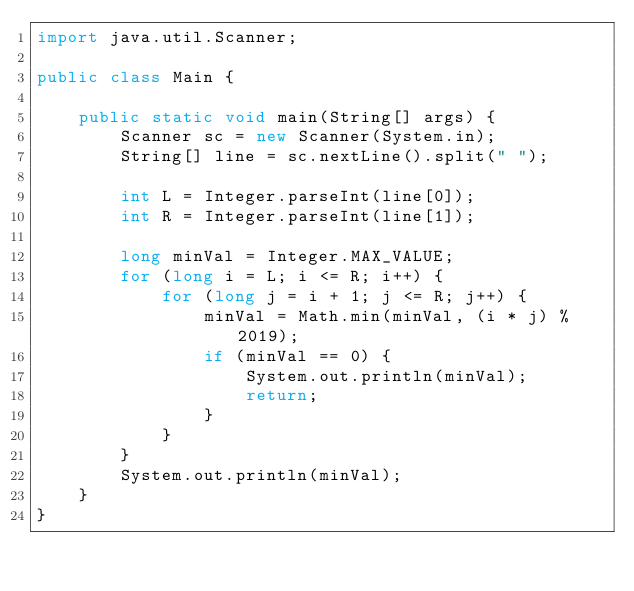<code> <loc_0><loc_0><loc_500><loc_500><_Java_>import java.util.Scanner;

public class Main {

	public static void main(String[] args) {
		Scanner sc = new Scanner(System.in);
		String[] line = sc.nextLine().split(" ");

		int L = Integer.parseInt(line[0]);
		int R = Integer.parseInt(line[1]);

		long minVal = Integer.MAX_VALUE;
		for (long i = L; i <= R; i++) {
			for (long j = i + 1; j <= R; j++) {
				minVal = Math.min(minVal, (i * j) % 2019);
				if (minVal == 0) {
					System.out.println(minVal);
					return;
				}
			}
		}
		System.out.println(minVal);
	}
}</code> 